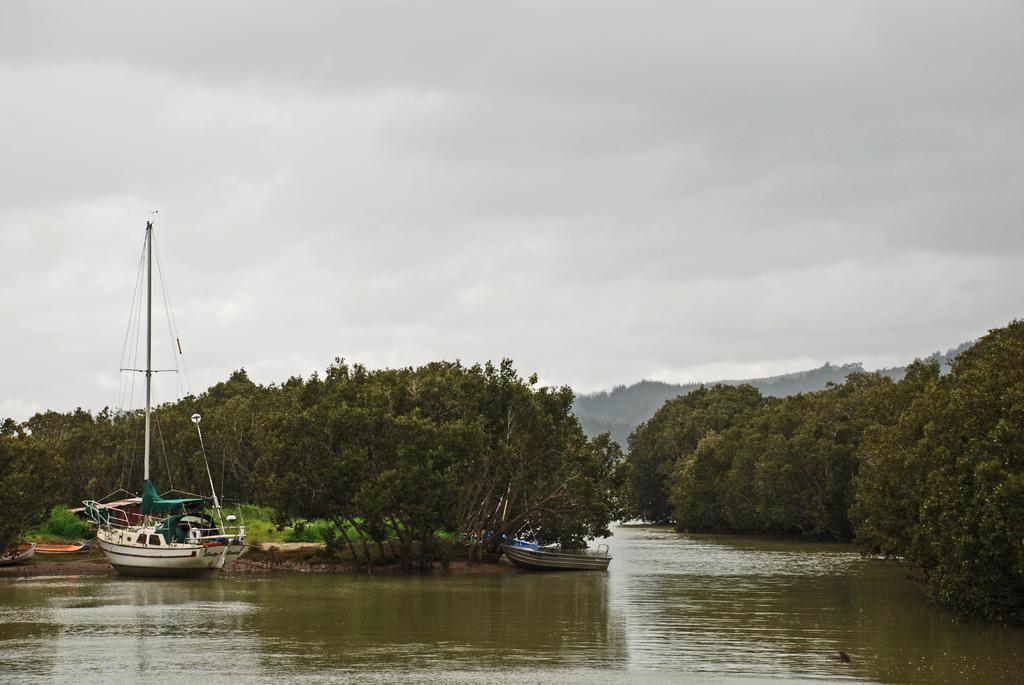In one or two sentences, can you explain what this image depicts? In this picture I can see the water in front, on which there are few boats and in the middle of this picture I can see number of trees. In the background I can see the cloudy sky. 